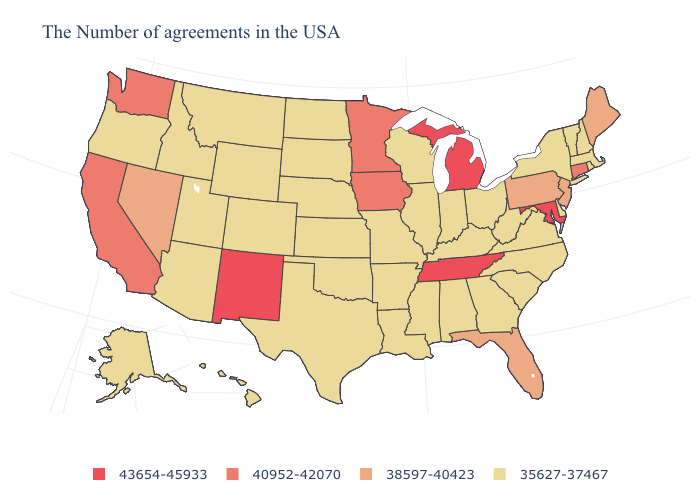What is the highest value in states that border Indiana?
Be succinct. 43654-45933. What is the value of Montana?
Keep it brief. 35627-37467. What is the lowest value in the Northeast?
Write a very short answer. 35627-37467. What is the value of Illinois?
Answer briefly. 35627-37467. Does the first symbol in the legend represent the smallest category?
Be succinct. No. What is the lowest value in the USA?
Concise answer only. 35627-37467. Among the states that border Rhode Island , which have the lowest value?
Keep it brief. Massachusetts. Does New Mexico have the highest value in the West?
Short answer required. Yes. What is the value of Kansas?
Keep it brief. 35627-37467. Does the first symbol in the legend represent the smallest category?
Write a very short answer. No. Does Minnesota have a higher value than New Mexico?
Give a very brief answer. No. What is the lowest value in the USA?
Write a very short answer. 35627-37467. What is the value of West Virginia?
Answer briefly. 35627-37467. Name the states that have a value in the range 35627-37467?
Short answer required. Massachusetts, Rhode Island, New Hampshire, Vermont, New York, Delaware, Virginia, North Carolina, South Carolina, West Virginia, Ohio, Georgia, Kentucky, Indiana, Alabama, Wisconsin, Illinois, Mississippi, Louisiana, Missouri, Arkansas, Kansas, Nebraska, Oklahoma, Texas, South Dakota, North Dakota, Wyoming, Colorado, Utah, Montana, Arizona, Idaho, Oregon, Alaska, Hawaii. Among the states that border New York , which have the highest value?
Quick response, please. Connecticut. 